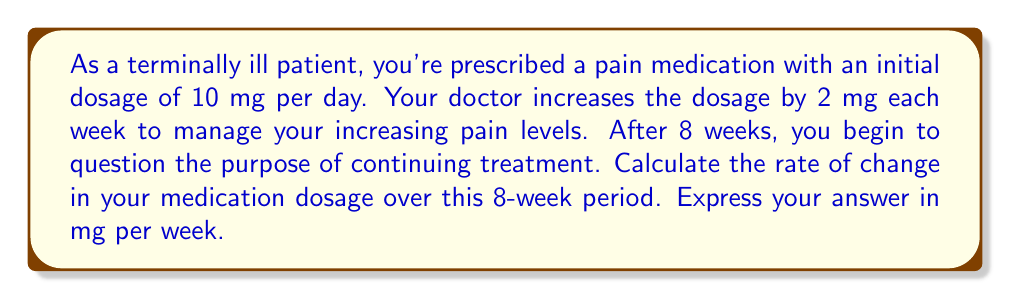Show me your answer to this math problem. Let's approach this step-by-step:

1) First, we need to identify the important information:
   - Initial dosage: 10 mg per day
   - Increase: 2 mg per week
   - Time period: 8 weeks

2) To calculate the rate of change, we use the formula:

   $$ \text{Rate of change} = \frac{\text{Change in dosage}}{\text{Change in time}} $$

3) Change in dosage:
   - Initial dosage: 10 mg
   - Final dosage after 8 weeks: $10 + (8 \times 2) = 26$ mg
   - Total change: $26 - 10 = 16$ mg

4) Change in time: 8 weeks

5) Now, let's plug these values into our formula:

   $$ \text{Rate of change} = \frac{16 \text{ mg}}{8 \text{ weeks}} = 2 \text{ mg/week} $$

This result aligns with the given information that the dosage increases by 2 mg each week.
Answer: The rate of change in medication dosage is $2 \text{ mg/week}$. 